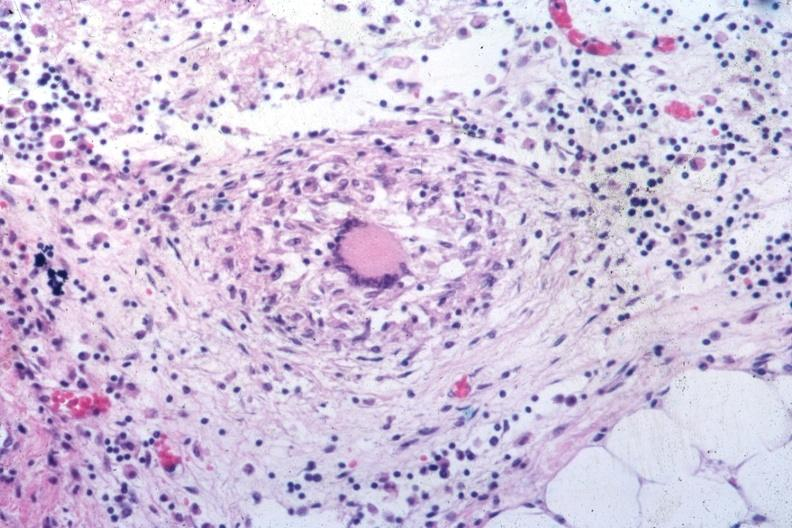s tuberculosis present?
Answer the question using a single word or phrase. Yes 